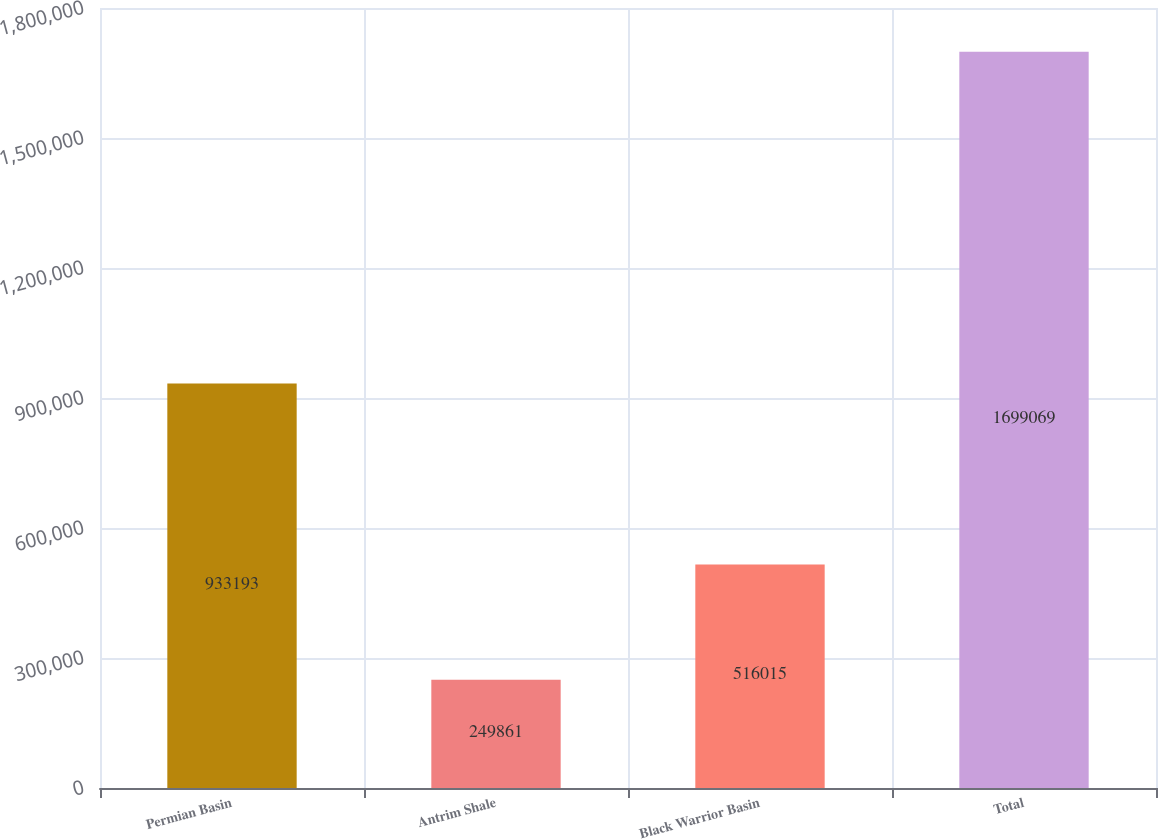<chart> <loc_0><loc_0><loc_500><loc_500><bar_chart><fcel>Permian Basin<fcel>Antrim Shale<fcel>Black Warrior Basin<fcel>Total<nl><fcel>933193<fcel>249861<fcel>516015<fcel>1.69907e+06<nl></chart> 